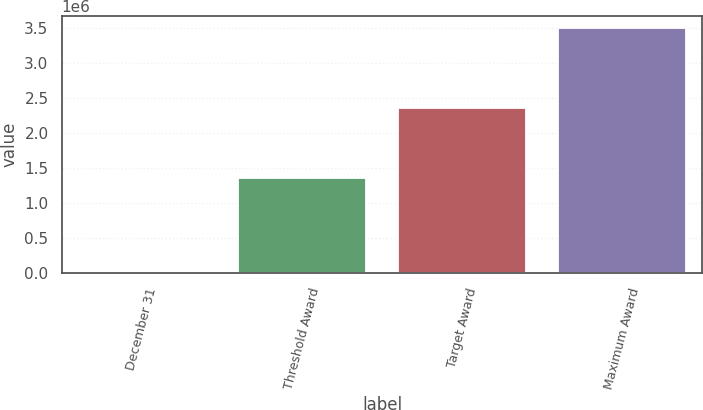Convert chart to OTSL. <chart><loc_0><loc_0><loc_500><loc_500><bar_chart><fcel>December 31<fcel>Threshold Award<fcel>Target Award<fcel>Maximum Award<nl><fcel>2005<fcel>1.35239e+06<fcel>2.35673e+06<fcel>3.49909e+06<nl></chart> 